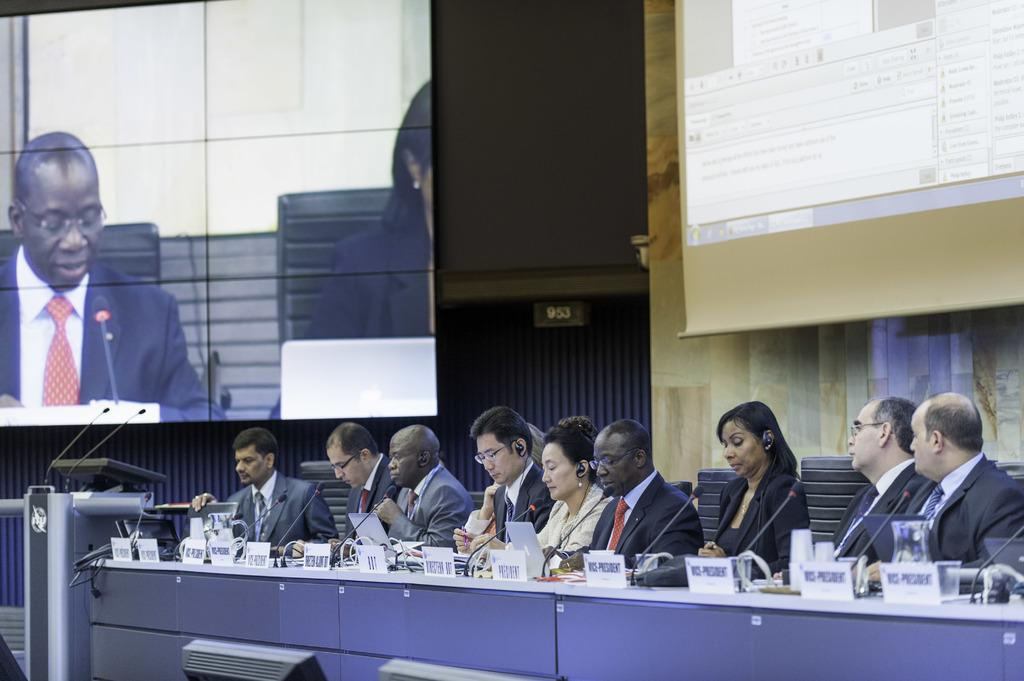What are the people in the image doing? There is a group of people sitting on chairs in the image. What is on the table in the image? There is a table in the image with name boards, microphones, and other things on it. What can be seen in the background of the image? Screens are present in the background of the image. What type of act is being performed on the table in the image? There is no act being performed on the table in the image; it contains name boards, microphones, and other items. 